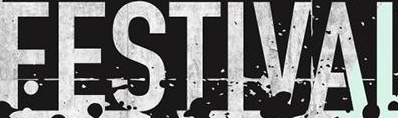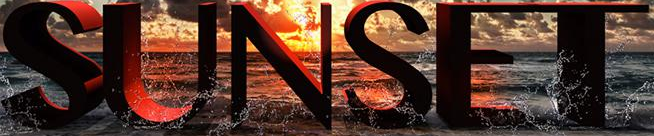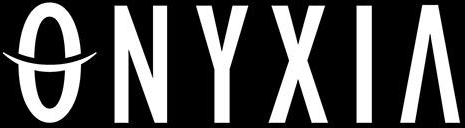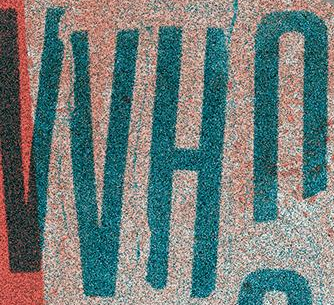Identify the words shown in these images in order, separated by a semicolon. FESTIVAI; SUNSET; ONYXIA; VVHn 